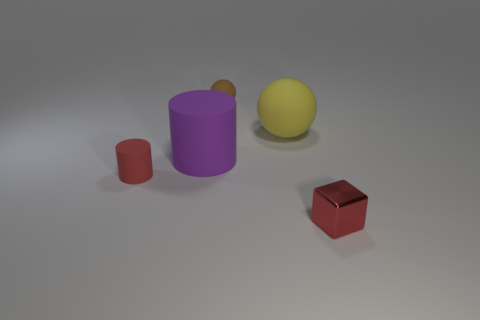Is there any other thing that is made of the same material as the tiny red block?
Your answer should be compact. No. Do the red thing that is behind the small metallic object and the red object in front of the small cylinder have the same size?
Offer a terse response. Yes. What color is the matte cylinder behind the matte thing that is on the left side of the purple cylinder?
Offer a terse response. Purple. There is a brown thing that is the same size as the block; what is its material?
Your answer should be compact. Rubber. How many matte objects are either purple balls or brown things?
Your response must be concise. 1. What color is the thing that is to the right of the tiny matte sphere and in front of the large yellow thing?
Your response must be concise. Red. What number of red matte cylinders are behind the tiny metallic thing?
Give a very brief answer. 1. What material is the big ball?
Your response must be concise. Rubber. There is a cylinder that is right of the tiny red thing on the left side of the small object behind the big yellow thing; what color is it?
Provide a short and direct response. Purple. What number of yellow spheres have the same size as the yellow matte object?
Give a very brief answer. 0. 